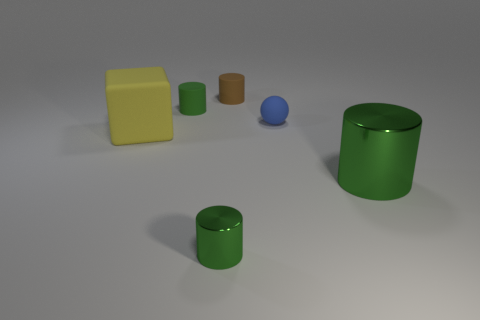Subtract all tiny brown rubber cylinders. How many cylinders are left? 3 Add 3 small green metal cylinders. How many objects exist? 9 Subtract 3 cylinders. How many cylinders are left? 1 Subtract all green cylinders. How many cylinders are left? 1 Subtract all balls. How many objects are left? 5 Subtract all gray cylinders. Subtract all yellow spheres. How many cylinders are left? 4 Subtract all green balls. How many green cylinders are left? 3 Subtract all green rubber cylinders. Subtract all brown matte cylinders. How many objects are left? 4 Add 4 green rubber objects. How many green rubber objects are left? 5 Add 3 yellow rubber objects. How many yellow rubber objects exist? 4 